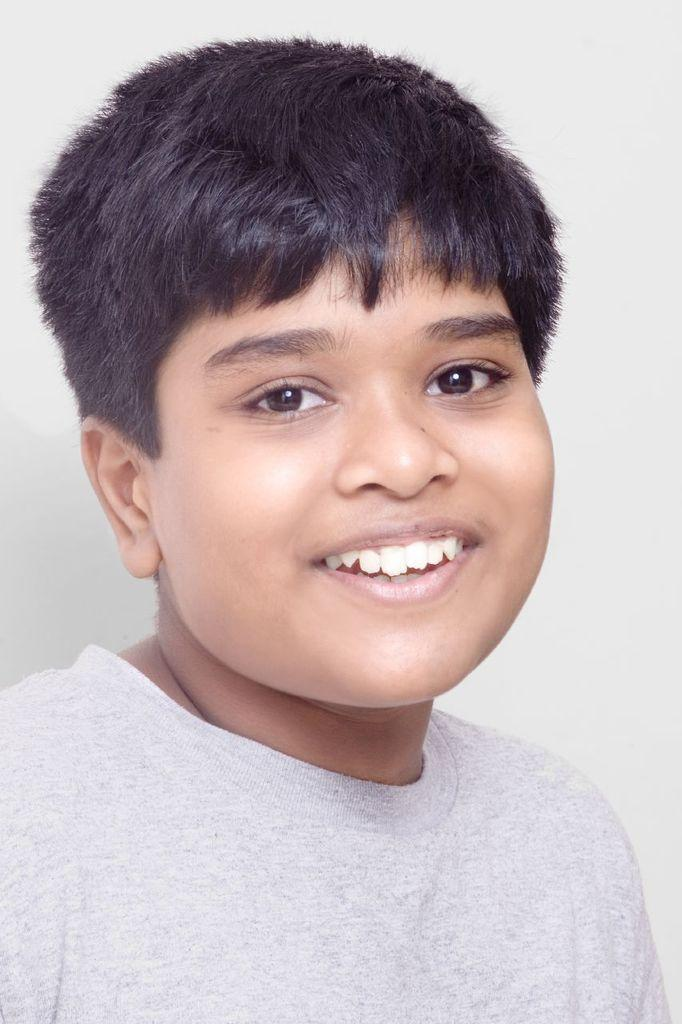Who is the main subject in the image? There is a boy in the image. What expression does the boy have? The boy is smiling. What color is the background of the image? The background of the image is white. What type of trees can be seen in the background of the image? There are no trees visible in the image, as the background is white. 